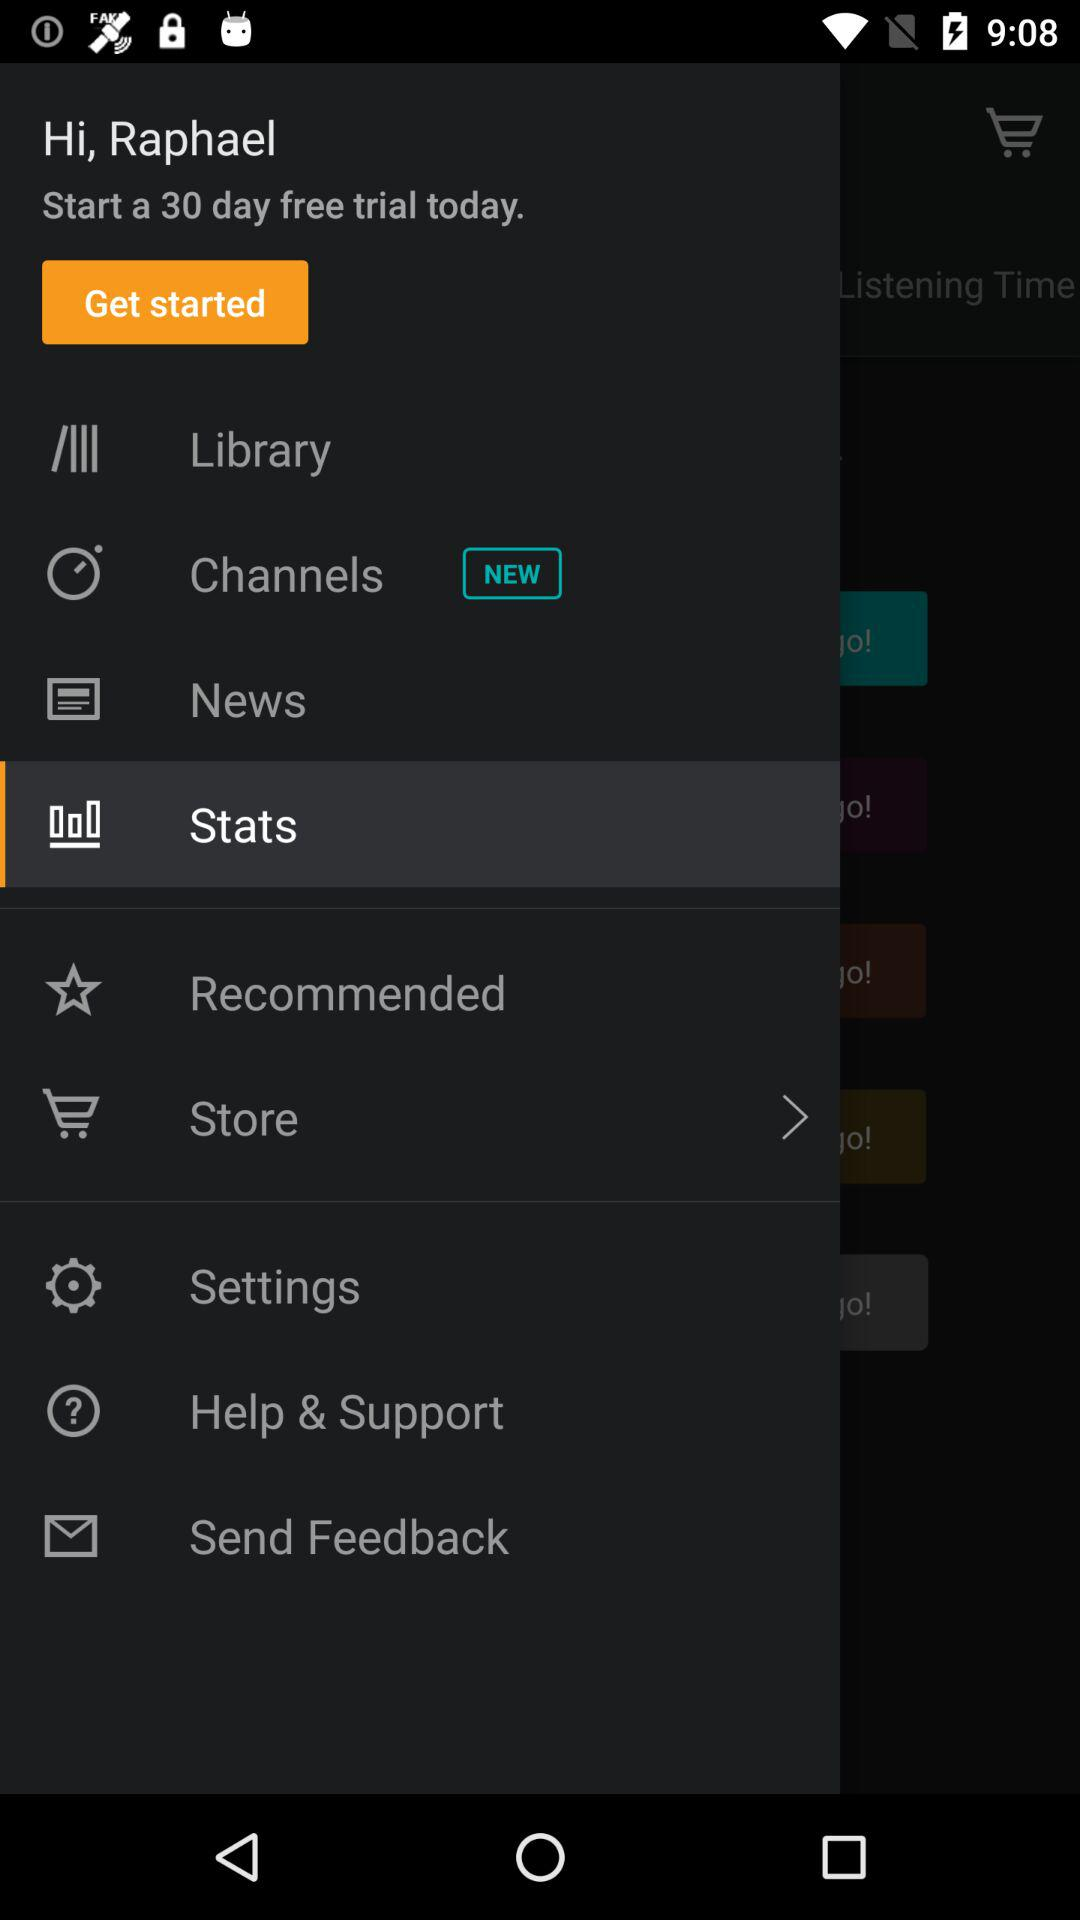How many days of a free trial are there? There are 30 days of a free trial. 